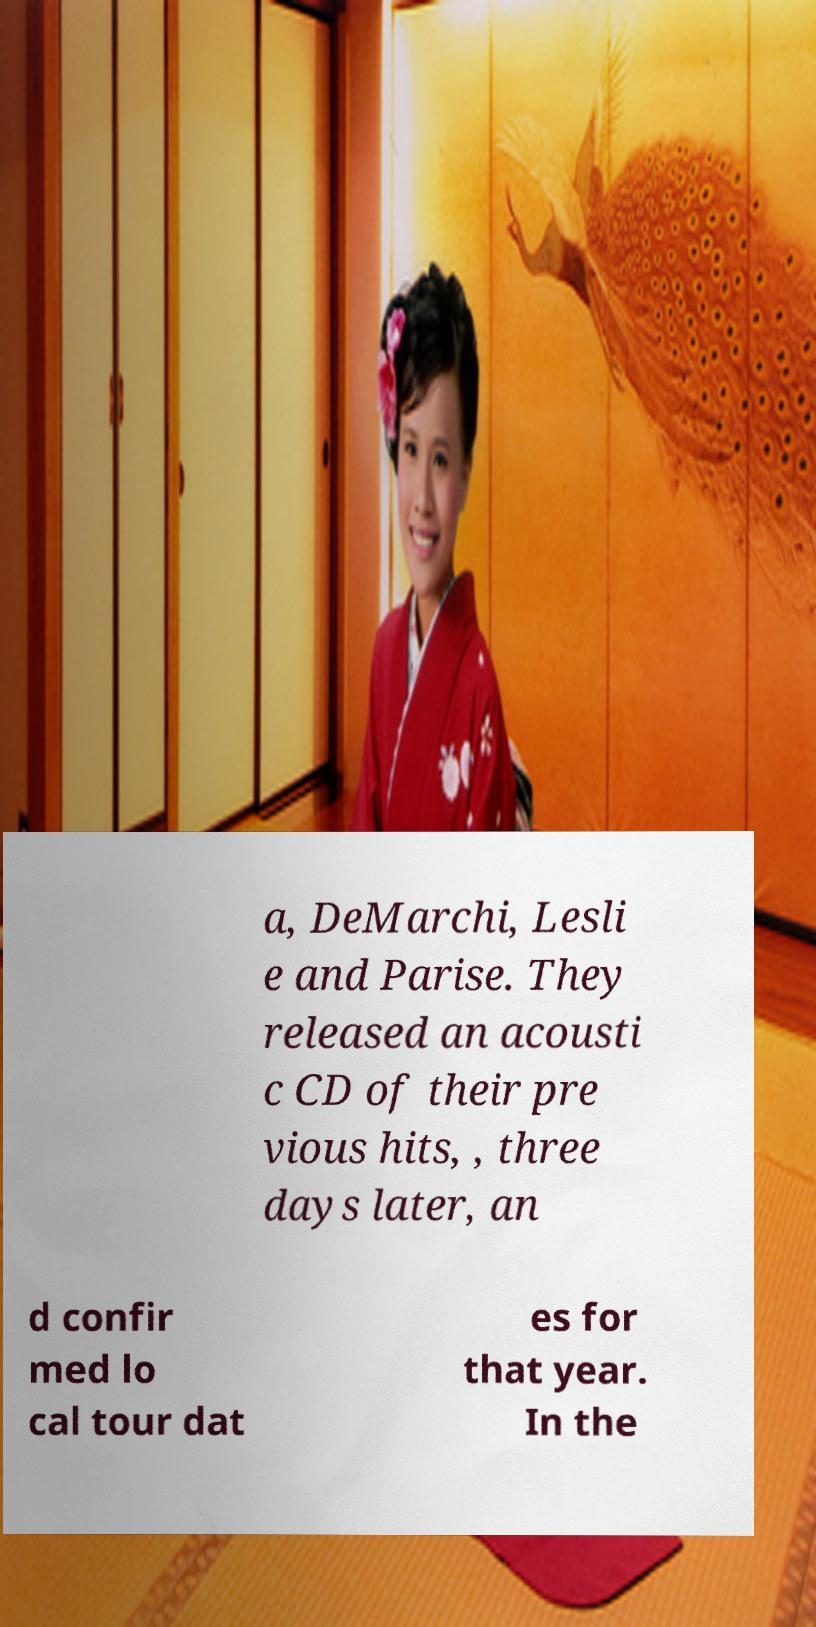Please identify and transcribe the text found in this image. a, DeMarchi, Lesli e and Parise. They released an acousti c CD of their pre vious hits, , three days later, an d confir med lo cal tour dat es for that year. In the 